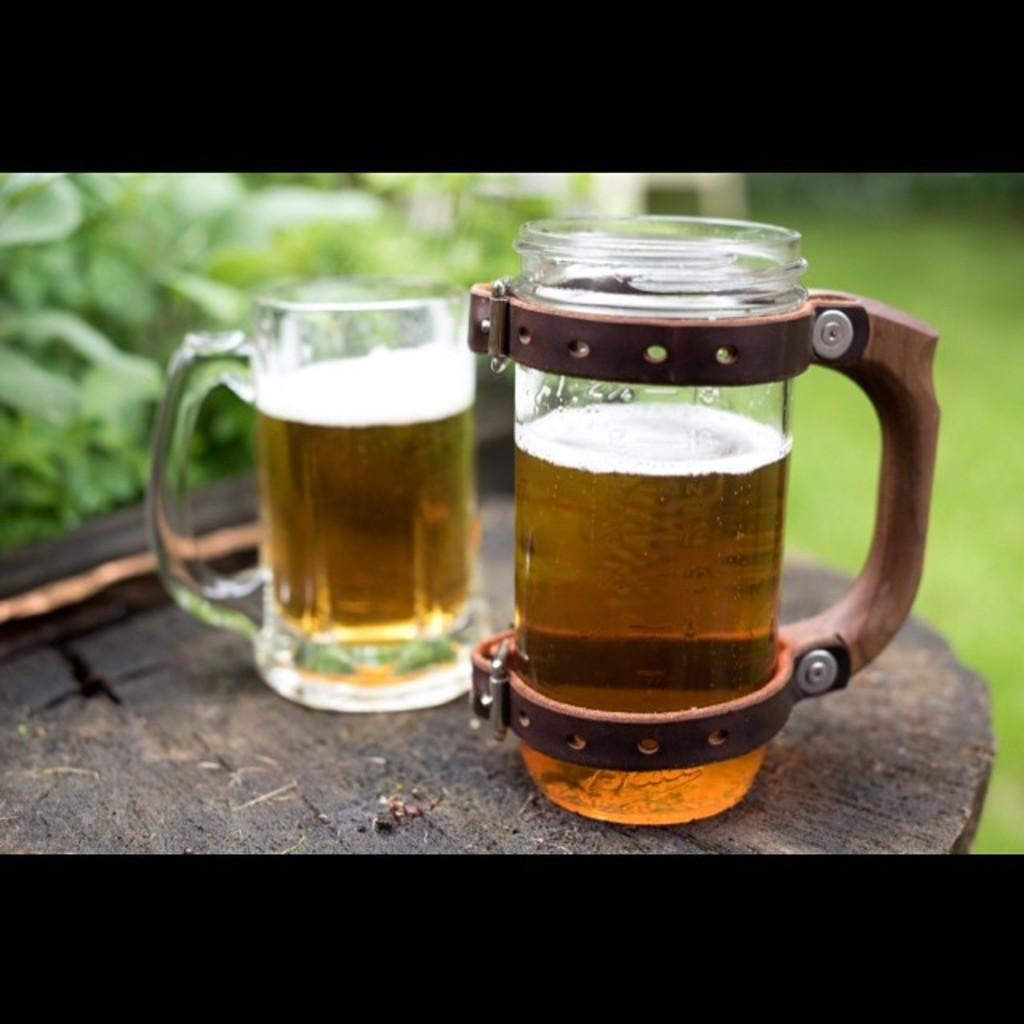How many mugs are visible in the image? There are two mugs in the image. What is the surface that the mugs are placed on? The mugs are on a wooden surface. What part of the image is in focus? The foreground area of the image is in focus. How would you describe the background of the image? The background of the image is blurry. What type of meal is being prepared in the image? There is no indication of a meal being prepared in the image; it only shows two mugs on a wooden surface. 